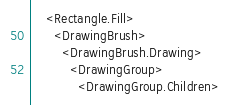Convert code to text. <code><loc_0><loc_0><loc_500><loc_500><_XML_>    <Rectangle.Fill>
      <DrawingBrush>
        <DrawingBrush.Drawing>
          <DrawingGroup>
            <DrawingGroup.Children></code> 